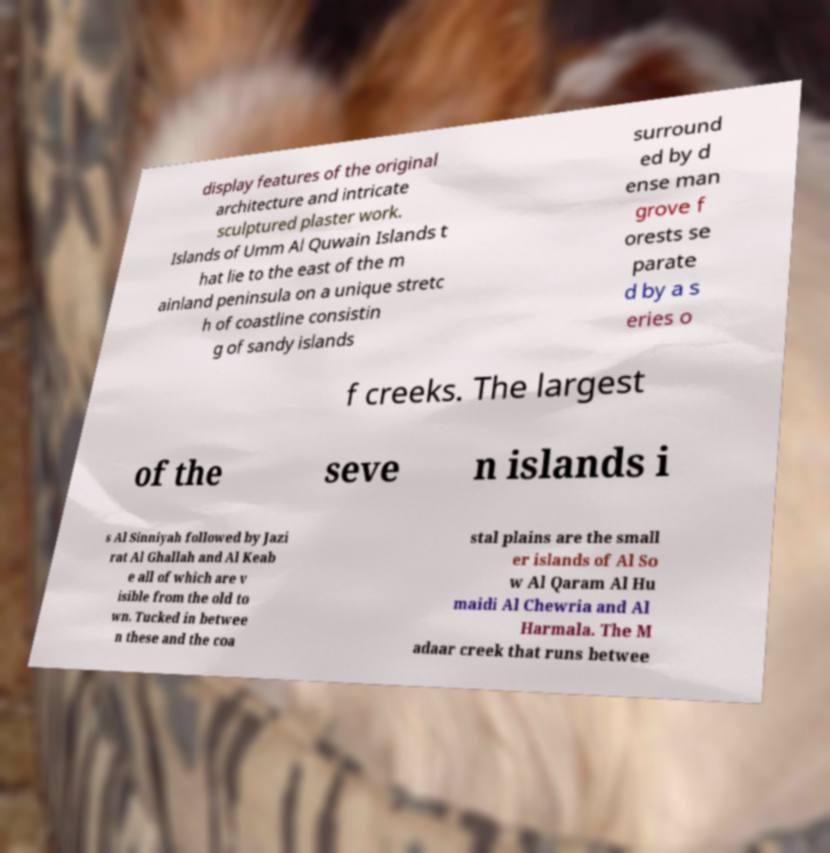What messages or text are displayed in this image? I need them in a readable, typed format. display features of the original architecture and intricate sculptured plaster work. Islands of Umm Al Quwain Islands t hat lie to the east of the m ainland peninsula on a unique stretc h of coastline consistin g of sandy islands surround ed by d ense man grove f orests se parate d by a s eries o f creeks. The largest of the seve n islands i s Al Sinniyah followed by Jazi rat Al Ghallah and Al Keab e all of which are v isible from the old to wn. Tucked in betwee n these and the coa stal plains are the small er islands of Al So w Al Qaram Al Hu maidi Al Chewria and Al Harmala. The M adaar creek that runs betwee 